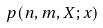Convert formula to latex. <formula><loc_0><loc_0><loc_500><loc_500>p ( n , m , X ; x )</formula> 